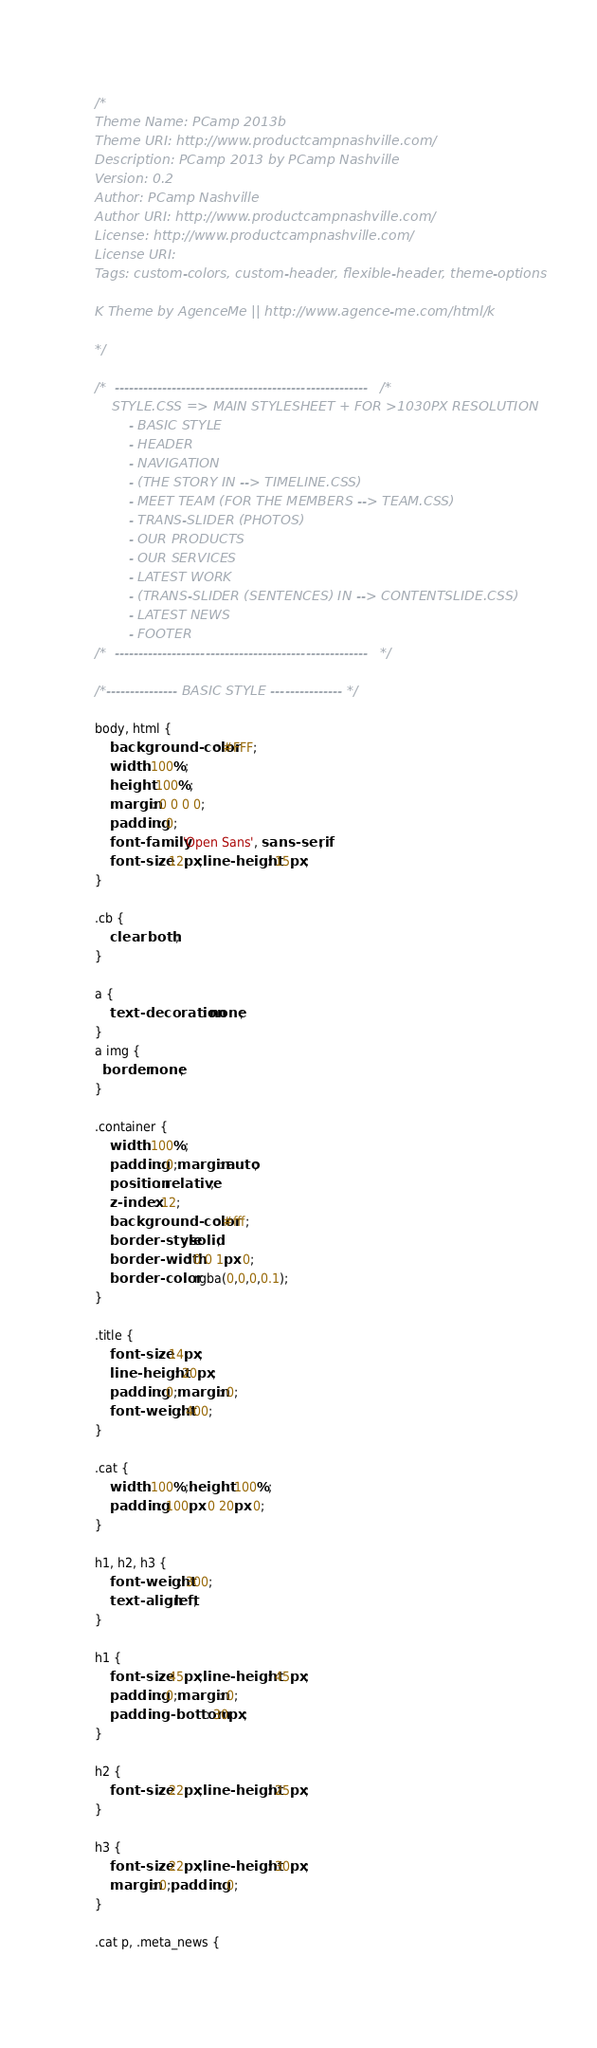<code> <loc_0><loc_0><loc_500><loc_500><_CSS_>/*
Theme Name: PCamp 2013b
Theme URI: http://www.productcampnashville.com/
Description: PCamp 2013 by PCamp Nashville
Version: 0.2
Author: PCamp Nashville
Author URI: http://www.productcampnashville.com/
License: http://www.productcampnashville.com/
License URI:
Tags: custom-colors, custom-header, flexible-header, theme-options

K Theme by AgenceMe || http://www.agence-me.com/html/k

*/

/*	-----------------------------------------------------   /*
	STYLE.CSS => MAIN STYLESHEET + FOR >1030PX RESOLUTION
		- BASIC STYLE
		- HEADER
		- NAVIGATION
		- (THE STORY IN --> TIMELINE.CSS)
		- MEET TEAM (FOR THE MEMBERS --> TEAM.CSS)
		- TRANS-SLIDER (PHOTOS)
		- OUR PRODUCTS
		- OUR SERVICES
		- LATEST WORK
		- (TRANS-SLIDER (SENTENCES) IN --> CONTENTSLIDE.CSS)
		- LATEST NEWS
		- FOOTER
/*	-----------------------------------------------------   */

/*--------------- BASIC STYLE --------------- */

body, html {
	background-color: #FFF;
	width: 100%;
	height: 100%;
	margin: 0 0 0 0;
	padding: 0;
	font-family: 'Open Sans', sans-serif;
	font-size: 12px;line-height: 15px;
}

.cb {
	clear: both;
}

a {
	text-decoration: none;
}
a img {
  border: none;
}

.container {
	width: 100%;
	padding: 0;margin: auto;
	position: relative;
	z-index: 12;
	background-color: #fff;
	border-style: solid;
	border-width: 0 0 1px 0;
	border-color:  rgba(0,0,0,0.1);
}

.title {
	font-size: 14px;
	line-height: 20px;
	padding: 0;margin: 0;
	font-weight: 400;
}

.cat {
	width: 100%;height: 100%;
	padding: 100px 0 20px 0;
}

h1, h2, h3 {
	font-weight: 300;
	text-align: left;
}

h1 {
	font-size: 45px;line-height: 45px;
	padding: 0;margin: 0;
	padding-bottom: 30px;
}

h2 {
	font-size: 22px;line-height: 25px;
}

h3 {
	font-size: 22px;line-height: 30px;
	margin: 0;padding: 0;
}

.cat p, .meta_news {</code> 